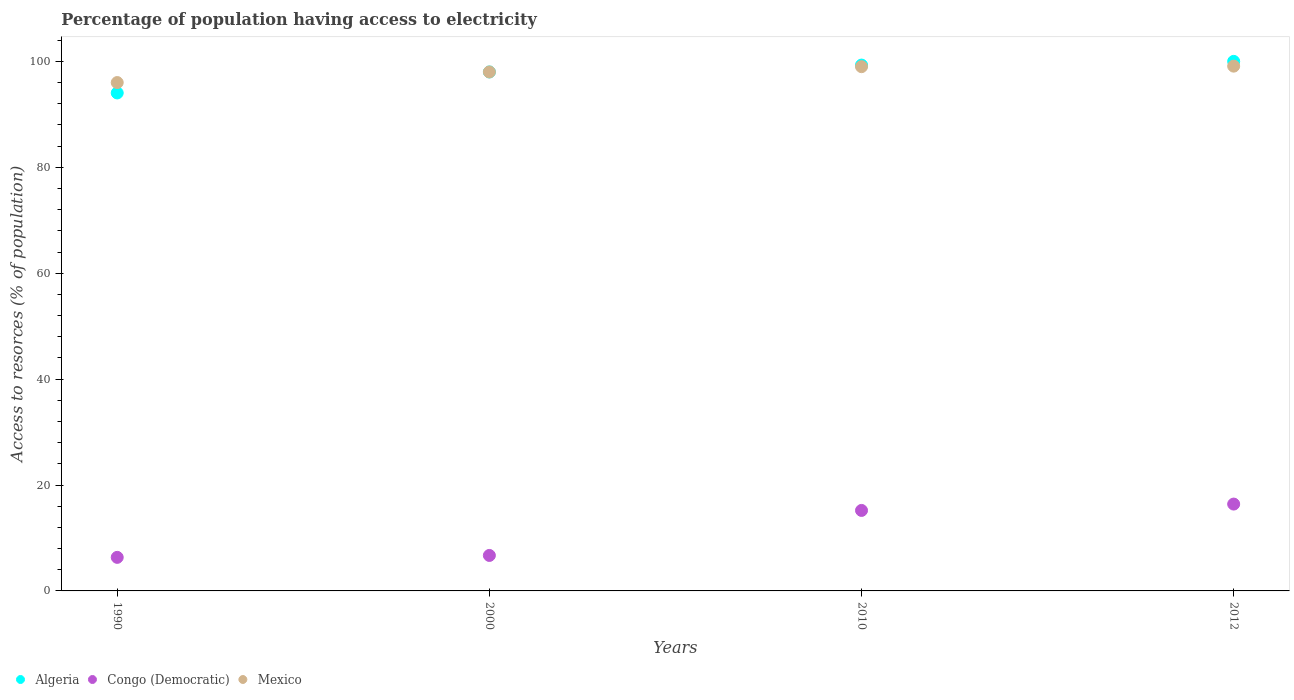How many different coloured dotlines are there?
Ensure brevity in your answer.  3. Is the number of dotlines equal to the number of legend labels?
Make the answer very short. Yes. What is the percentage of population having access to electricity in Congo (Democratic) in 2000?
Give a very brief answer. 6.7. Across all years, what is the maximum percentage of population having access to electricity in Congo (Democratic)?
Your response must be concise. 16.4. Across all years, what is the minimum percentage of population having access to electricity in Mexico?
Your answer should be very brief. 96. In which year was the percentage of population having access to electricity in Congo (Democratic) maximum?
Offer a very short reply. 2012. What is the total percentage of population having access to electricity in Algeria in the graph?
Provide a succinct answer. 391.34. What is the difference between the percentage of population having access to electricity in Congo (Democratic) in 1990 and that in 2000?
Provide a succinct answer. -0.36. What is the difference between the percentage of population having access to electricity in Congo (Democratic) in 1990 and the percentage of population having access to electricity in Mexico in 2012?
Provide a short and direct response. -92.76. What is the average percentage of population having access to electricity in Algeria per year?
Provide a succinct answer. 97.83. In the year 1990, what is the difference between the percentage of population having access to electricity in Algeria and percentage of population having access to electricity in Mexico?
Offer a terse response. -1.96. In how many years, is the percentage of population having access to electricity in Congo (Democratic) greater than 40 %?
Provide a succinct answer. 0. What is the ratio of the percentage of population having access to electricity in Mexico in 1990 to that in 2000?
Give a very brief answer. 0.98. What is the difference between the highest and the second highest percentage of population having access to electricity in Algeria?
Provide a short and direct response. 0.7. What is the difference between the highest and the lowest percentage of population having access to electricity in Mexico?
Keep it short and to the point. 3.1. Is it the case that in every year, the sum of the percentage of population having access to electricity in Mexico and percentage of population having access to electricity in Congo (Democratic)  is greater than the percentage of population having access to electricity in Algeria?
Offer a very short reply. Yes. Does the percentage of population having access to electricity in Algeria monotonically increase over the years?
Offer a very short reply. Yes. Is the percentage of population having access to electricity in Algeria strictly less than the percentage of population having access to electricity in Congo (Democratic) over the years?
Ensure brevity in your answer.  No. How many dotlines are there?
Offer a very short reply. 3. Does the graph contain any zero values?
Make the answer very short. No. Does the graph contain grids?
Offer a terse response. No. What is the title of the graph?
Provide a succinct answer. Percentage of population having access to electricity. What is the label or title of the Y-axis?
Provide a short and direct response. Access to resorces (% of population). What is the Access to resorces (% of population) in Algeria in 1990?
Provide a short and direct response. 94.04. What is the Access to resorces (% of population) of Congo (Democratic) in 1990?
Give a very brief answer. 6.34. What is the Access to resorces (% of population) of Mexico in 1990?
Provide a succinct answer. 96. What is the Access to resorces (% of population) in Congo (Democratic) in 2000?
Your answer should be compact. 6.7. What is the Access to resorces (% of population) of Algeria in 2010?
Provide a succinct answer. 99.3. What is the Access to resorces (% of population) of Mexico in 2010?
Your response must be concise. 99. What is the Access to resorces (% of population) in Algeria in 2012?
Provide a succinct answer. 100. What is the Access to resorces (% of population) of Congo (Democratic) in 2012?
Offer a terse response. 16.4. What is the Access to resorces (% of population) in Mexico in 2012?
Your answer should be compact. 99.1. Across all years, what is the maximum Access to resorces (% of population) in Algeria?
Offer a terse response. 100. Across all years, what is the maximum Access to resorces (% of population) in Congo (Democratic)?
Give a very brief answer. 16.4. Across all years, what is the maximum Access to resorces (% of population) in Mexico?
Provide a short and direct response. 99.1. Across all years, what is the minimum Access to resorces (% of population) of Algeria?
Keep it short and to the point. 94.04. Across all years, what is the minimum Access to resorces (% of population) in Congo (Democratic)?
Offer a very short reply. 6.34. Across all years, what is the minimum Access to resorces (% of population) of Mexico?
Your answer should be very brief. 96. What is the total Access to resorces (% of population) in Algeria in the graph?
Provide a succinct answer. 391.34. What is the total Access to resorces (% of population) of Congo (Democratic) in the graph?
Ensure brevity in your answer.  44.64. What is the total Access to resorces (% of population) in Mexico in the graph?
Offer a very short reply. 392.1. What is the difference between the Access to resorces (% of population) of Algeria in 1990 and that in 2000?
Make the answer very short. -3.96. What is the difference between the Access to resorces (% of population) in Congo (Democratic) in 1990 and that in 2000?
Keep it short and to the point. -0.36. What is the difference between the Access to resorces (% of population) of Algeria in 1990 and that in 2010?
Give a very brief answer. -5.26. What is the difference between the Access to resorces (% of population) in Congo (Democratic) in 1990 and that in 2010?
Provide a succinct answer. -8.86. What is the difference between the Access to resorces (% of population) in Mexico in 1990 and that in 2010?
Provide a succinct answer. -3. What is the difference between the Access to resorces (% of population) of Algeria in 1990 and that in 2012?
Provide a succinct answer. -5.96. What is the difference between the Access to resorces (% of population) in Congo (Democratic) in 1990 and that in 2012?
Offer a very short reply. -10.06. What is the difference between the Access to resorces (% of population) in Congo (Democratic) in 2000 and that in 2010?
Your answer should be very brief. -8.5. What is the difference between the Access to resorces (% of population) of Algeria in 2000 and that in 2012?
Offer a very short reply. -2. What is the difference between the Access to resorces (% of population) of Congo (Democratic) in 2000 and that in 2012?
Ensure brevity in your answer.  -9.7. What is the difference between the Access to resorces (% of population) of Algeria in 2010 and that in 2012?
Offer a terse response. -0.7. What is the difference between the Access to resorces (% of population) of Congo (Democratic) in 2010 and that in 2012?
Offer a very short reply. -1.2. What is the difference between the Access to resorces (% of population) of Mexico in 2010 and that in 2012?
Provide a short and direct response. -0.1. What is the difference between the Access to resorces (% of population) of Algeria in 1990 and the Access to resorces (% of population) of Congo (Democratic) in 2000?
Give a very brief answer. 87.34. What is the difference between the Access to resorces (% of population) in Algeria in 1990 and the Access to resorces (% of population) in Mexico in 2000?
Offer a terse response. -3.96. What is the difference between the Access to resorces (% of population) in Congo (Democratic) in 1990 and the Access to resorces (% of population) in Mexico in 2000?
Give a very brief answer. -91.66. What is the difference between the Access to resorces (% of population) of Algeria in 1990 and the Access to resorces (% of population) of Congo (Democratic) in 2010?
Make the answer very short. 78.84. What is the difference between the Access to resorces (% of population) of Algeria in 1990 and the Access to resorces (% of population) of Mexico in 2010?
Keep it short and to the point. -4.96. What is the difference between the Access to resorces (% of population) of Congo (Democratic) in 1990 and the Access to resorces (% of population) of Mexico in 2010?
Offer a terse response. -92.66. What is the difference between the Access to resorces (% of population) of Algeria in 1990 and the Access to resorces (% of population) of Congo (Democratic) in 2012?
Ensure brevity in your answer.  77.64. What is the difference between the Access to resorces (% of population) of Algeria in 1990 and the Access to resorces (% of population) of Mexico in 2012?
Keep it short and to the point. -5.06. What is the difference between the Access to resorces (% of population) in Congo (Democratic) in 1990 and the Access to resorces (% of population) in Mexico in 2012?
Make the answer very short. -92.76. What is the difference between the Access to resorces (% of population) of Algeria in 2000 and the Access to resorces (% of population) of Congo (Democratic) in 2010?
Your answer should be compact. 82.8. What is the difference between the Access to resorces (% of population) in Algeria in 2000 and the Access to resorces (% of population) in Mexico in 2010?
Your response must be concise. -1. What is the difference between the Access to resorces (% of population) of Congo (Democratic) in 2000 and the Access to resorces (% of population) of Mexico in 2010?
Your answer should be very brief. -92.3. What is the difference between the Access to resorces (% of population) in Algeria in 2000 and the Access to resorces (% of population) in Congo (Democratic) in 2012?
Ensure brevity in your answer.  81.6. What is the difference between the Access to resorces (% of population) of Algeria in 2000 and the Access to resorces (% of population) of Mexico in 2012?
Offer a very short reply. -1.1. What is the difference between the Access to resorces (% of population) of Congo (Democratic) in 2000 and the Access to resorces (% of population) of Mexico in 2012?
Offer a very short reply. -92.4. What is the difference between the Access to resorces (% of population) of Algeria in 2010 and the Access to resorces (% of population) of Congo (Democratic) in 2012?
Make the answer very short. 82.9. What is the difference between the Access to resorces (% of population) of Algeria in 2010 and the Access to resorces (% of population) of Mexico in 2012?
Offer a terse response. 0.2. What is the difference between the Access to resorces (% of population) in Congo (Democratic) in 2010 and the Access to resorces (% of population) in Mexico in 2012?
Your response must be concise. -83.9. What is the average Access to resorces (% of population) of Algeria per year?
Offer a very short reply. 97.83. What is the average Access to resorces (% of population) in Congo (Democratic) per year?
Ensure brevity in your answer.  11.16. What is the average Access to resorces (% of population) of Mexico per year?
Your answer should be very brief. 98.03. In the year 1990, what is the difference between the Access to resorces (% of population) of Algeria and Access to resorces (% of population) of Congo (Democratic)?
Give a very brief answer. 87.7. In the year 1990, what is the difference between the Access to resorces (% of population) in Algeria and Access to resorces (% of population) in Mexico?
Provide a short and direct response. -1.96. In the year 1990, what is the difference between the Access to resorces (% of population) of Congo (Democratic) and Access to resorces (% of population) of Mexico?
Offer a very short reply. -89.66. In the year 2000, what is the difference between the Access to resorces (% of population) in Algeria and Access to resorces (% of population) in Congo (Democratic)?
Provide a short and direct response. 91.3. In the year 2000, what is the difference between the Access to resorces (% of population) of Algeria and Access to resorces (% of population) of Mexico?
Offer a terse response. 0. In the year 2000, what is the difference between the Access to resorces (% of population) of Congo (Democratic) and Access to resorces (% of population) of Mexico?
Offer a very short reply. -91.3. In the year 2010, what is the difference between the Access to resorces (% of population) in Algeria and Access to resorces (% of population) in Congo (Democratic)?
Keep it short and to the point. 84.1. In the year 2010, what is the difference between the Access to resorces (% of population) of Congo (Democratic) and Access to resorces (% of population) of Mexico?
Offer a very short reply. -83.8. In the year 2012, what is the difference between the Access to resorces (% of population) in Algeria and Access to resorces (% of population) in Congo (Democratic)?
Make the answer very short. 83.6. In the year 2012, what is the difference between the Access to resorces (% of population) in Congo (Democratic) and Access to resorces (% of population) in Mexico?
Your answer should be very brief. -82.7. What is the ratio of the Access to resorces (% of population) of Algeria in 1990 to that in 2000?
Give a very brief answer. 0.96. What is the ratio of the Access to resorces (% of population) in Congo (Democratic) in 1990 to that in 2000?
Your answer should be compact. 0.95. What is the ratio of the Access to resorces (% of population) in Mexico in 1990 to that in 2000?
Make the answer very short. 0.98. What is the ratio of the Access to resorces (% of population) in Algeria in 1990 to that in 2010?
Ensure brevity in your answer.  0.95. What is the ratio of the Access to resorces (% of population) of Congo (Democratic) in 1990 to that in 2010?
Your response must be concise. 0.42. What is the ratio of the Access to resorces (% of population) of Mexico in 1990 to that in 2010?
Provide a short and direct response. 0.97. What is the ratio of the Access to resorces (% of population) of Algeria in 1990 to that in 2012?
Make the answer very short. 0.94. What is the ratio of the Access to resorces (% of population) in Congo (Democratic) in 1990 to that in 2012?
Give a very brief answer. 0.39. What is the ratio of the Access to resorces (% of population) in Mexico in 1990 to that in 2012?
Offer a very short reply. 0.97. What is the ratio of the Access to resorces (% of population) of Algeria in 2000 to that in 2010?
Provide a short and direct response. 0.99. What is the ratio of the Access to resorces (% of population) of Congo (Democratic) in 2000 to that in 2010?
Make the answer very short. 0.44. What is the ratio of the Access to resorces (% of population) of Mexico in 2000 to that in 2010?
Make the answer very short. 0.99. What is the ratio of the Access to resorces (% of population) in Congo (Democratic) in 2000 to that in 2012?
Keep it short and to the point. 0.41. What is the ratio of the Access to resorces (% of population) in Mexico in 2000 to that in 2012?
Make the answer very short. 0.99. What is the ratio of the Access to resorces (% of population) in Congo (Democratic) in 2010 to that in 2012?
Provide a short and direct response. 0.93. What is the ratio of the Access to resorces (% of population) of Mexico in 2010 to that in 2012?
Ensure brevity in your answer.  1. What is the difference between the highest and the second highest Access to resorces (% of population) in Algeria?
Give a very brief answer. 0.7. What is the difference between the highest and the second highest Access to resorces (% of population) in Congo (Democratic)?
Offer a terse response. 1.2. What is the difference between the highest and the second highest Access to resorces (% of population) of Mexico?
Offer a terse response. 0.1. What is the difference between the highest and the lowest Access to resorces (% of population) of Algeria?
Provide a short and direct response. 5.96. What is the difference between the highest and the lowest Access to resorces (% of population) in Congo (Democratic)?
Provide a short and direct response. 10.06. What is the difference between the highest and the lowest Access to resorces (% of population) in Mexico?
Offer a terse response. 3.1. 